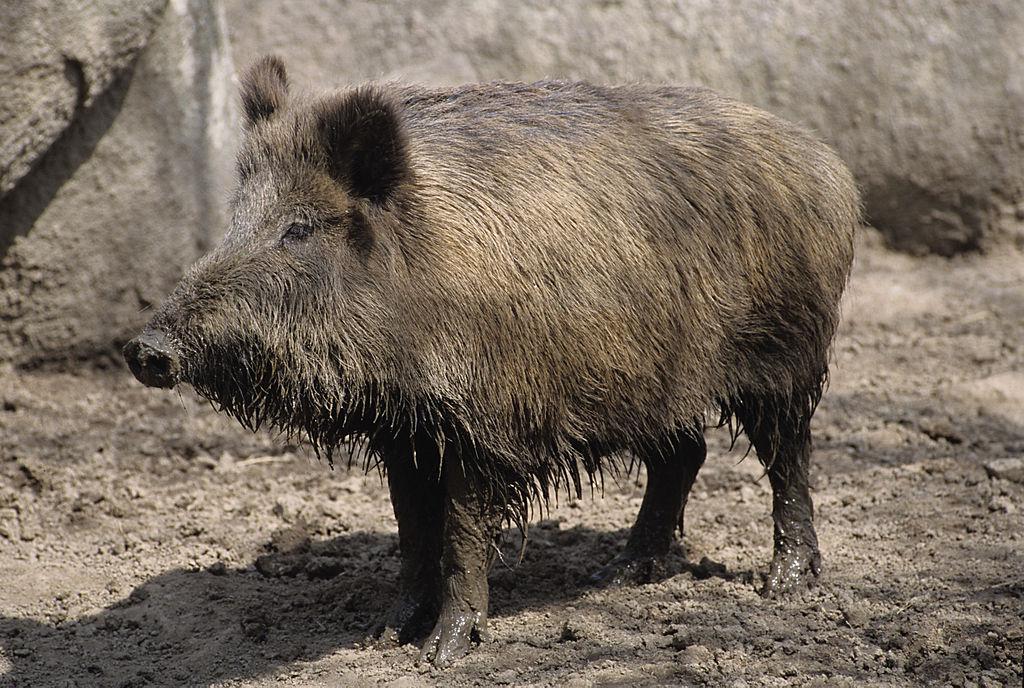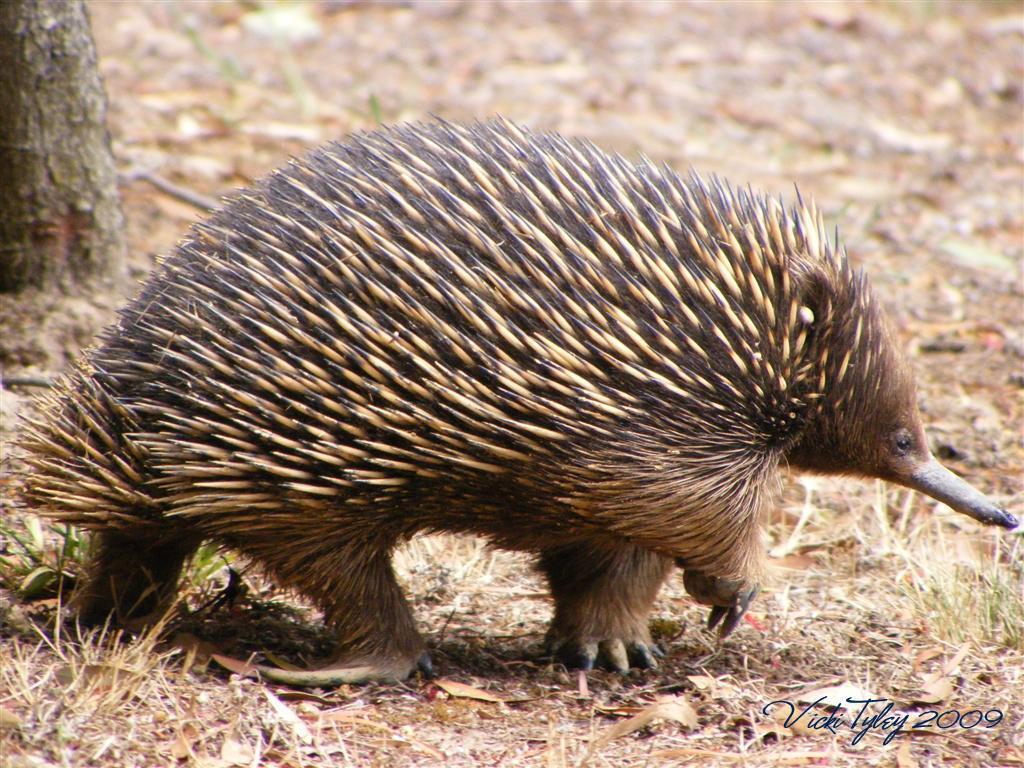The first image is the image on the left, the second image is the image on the right. Considering the images on both sides, is "A single animal is standing on the ground in the image on the right." valid? Answer yes or no. Yes. 